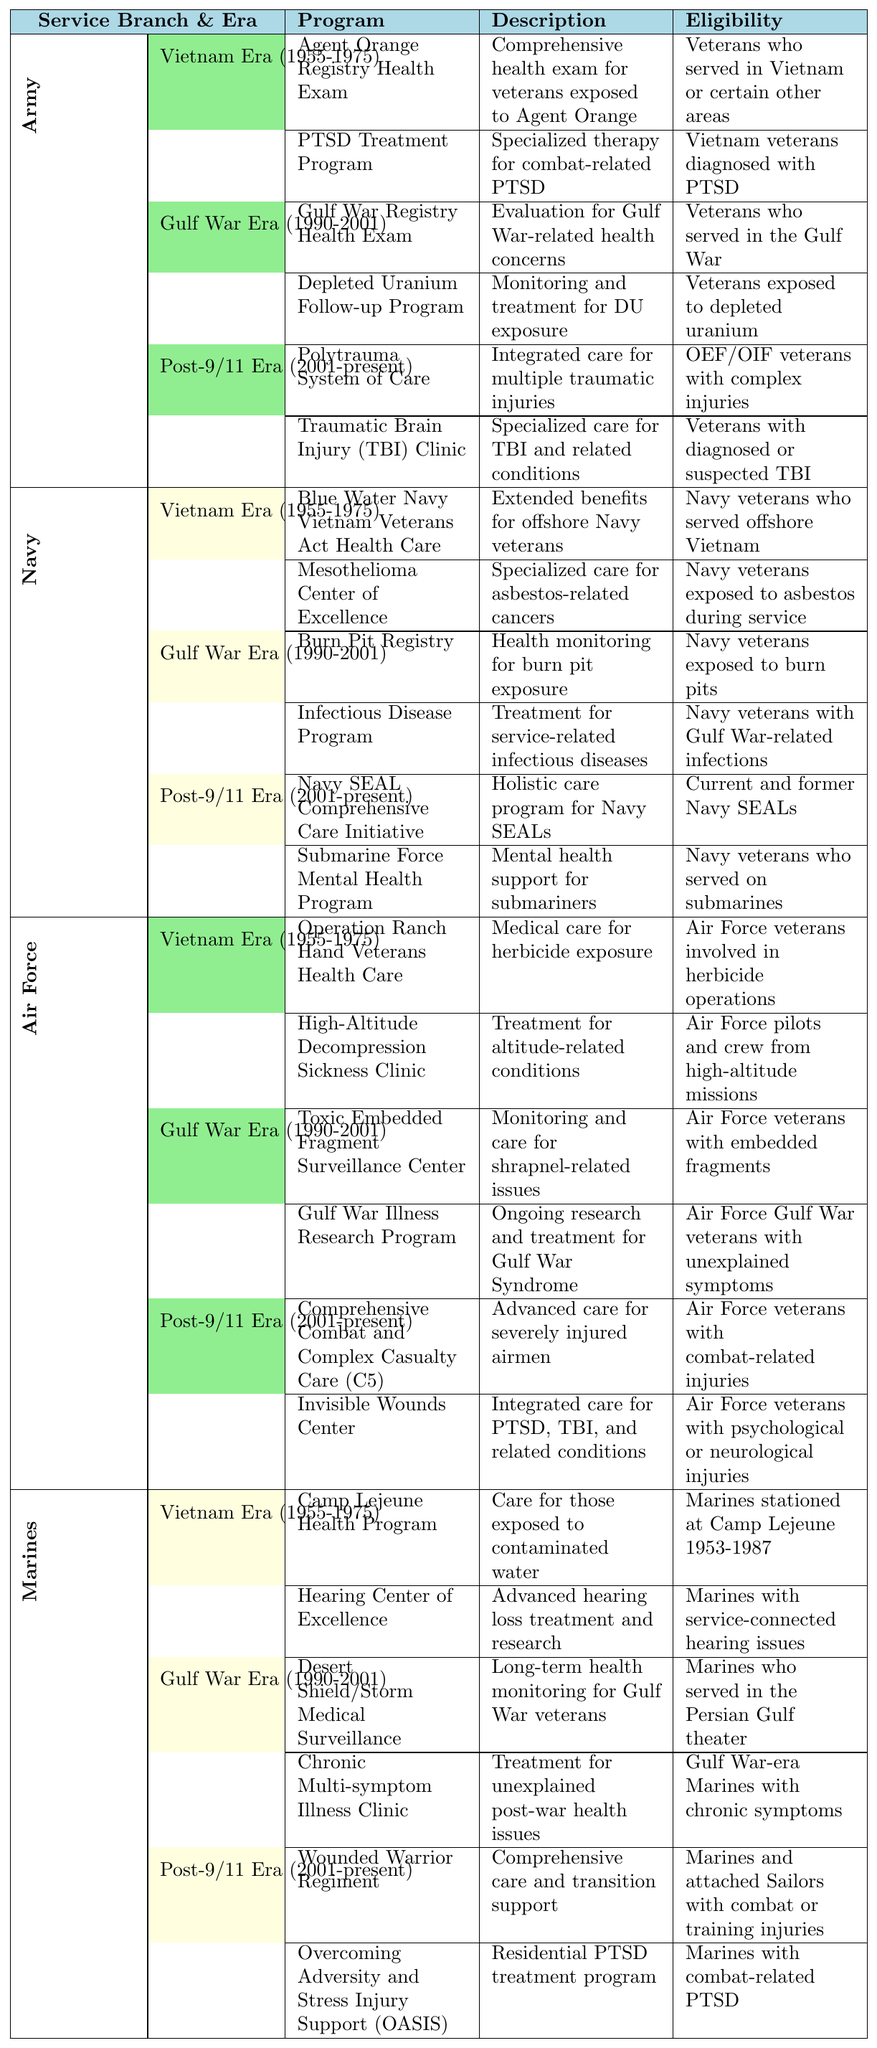What programs are available for Army veterans in the Post-9/11 Era? The table lists two programs under Army for the Post-9/11 Era: the Polytrauma System of Care, which provides integrated care for multiple traumatic injuries, and the Traumatic Brain Injury (TBI) Clinic, which focuses on specialized care for TBI and related conditions.
Answer: Polytrauma System of Care and Traumatic Brain Injury (TBI) Clinic Which service branch has a program for asbestos exposure during the Vietnam Era? In the Vietnam Era section, the Navy has the Mesothelioma Center of Excellence program that provides specialized care for asbestos-related cancers.
Answer: Navy How many programs are listed for the Gulf War Era for the Marines? The Marines have two programs listed for the Gulf War Era: the Desert Shield/Storm Medical Surveillance and the Chronic Multi-symptom Illness Clinic, totaling to two programs.
Answer: 2 Is there a specialized PTSD treatment program for veterans who served in Vietnam? Yes, the Army has a PTSD Treatment Program aimed at Vietnam veterans diagnosed with PTSD.
Answer: Yes Which service branch offers the Comprehensive Combat and Complex Casualty Care (C5) program? The Air Force offers the Comprehensive Combat and Complex Casualty Care (C5) program, which provides advanced care for severely injured airmen.
Answer: Air Force What is the eligibility requirement for the Blue Water Navy Vietnam Veterans Act Health Care program? The eligibility for this program requires Navy veterans who have served offshore Vietnam during the Vietnam Era.
Answer: Navy veterans who served offshore Vietnam Which program focuses on care related to herbicide exposure and which service branch offers it? The Operation Ranch Hand Veterans Health Care program provides medical care for herbicide exposure, and it is offered by the Air Force.
Answer: Operation Ranch Hand Veterans Health Care, Air Force How many programs for the Gulf War Era are focused on exposure to specific hazards? In the Gulf War Era, the Navy has the Burn Pit Registry for burn pit exposure, and the Army has the Depleted Uranium Follow-up Program for DU exposure, totaling two programs focused on specific hazards.
Answer: 2 Are there any Marine programs dedicated to health monitoring after the Gulf War? Yes, the Marines have the Desert Shield/Storm Medical Surveillance program dedicated to long-term health monitoring for Gulf War veterans.
Answer: Yes Which era has the least number of programs available for the Army? The Vietnam Era for the Army has two programs, the least compared to the Gulf War Era and Post-9/11 Era, each with two programs as well, indicating three different eras each with two programs.
Answer: Vietnam Era, Gulf War Era, and Post-9/11 Era all have 2 programs 